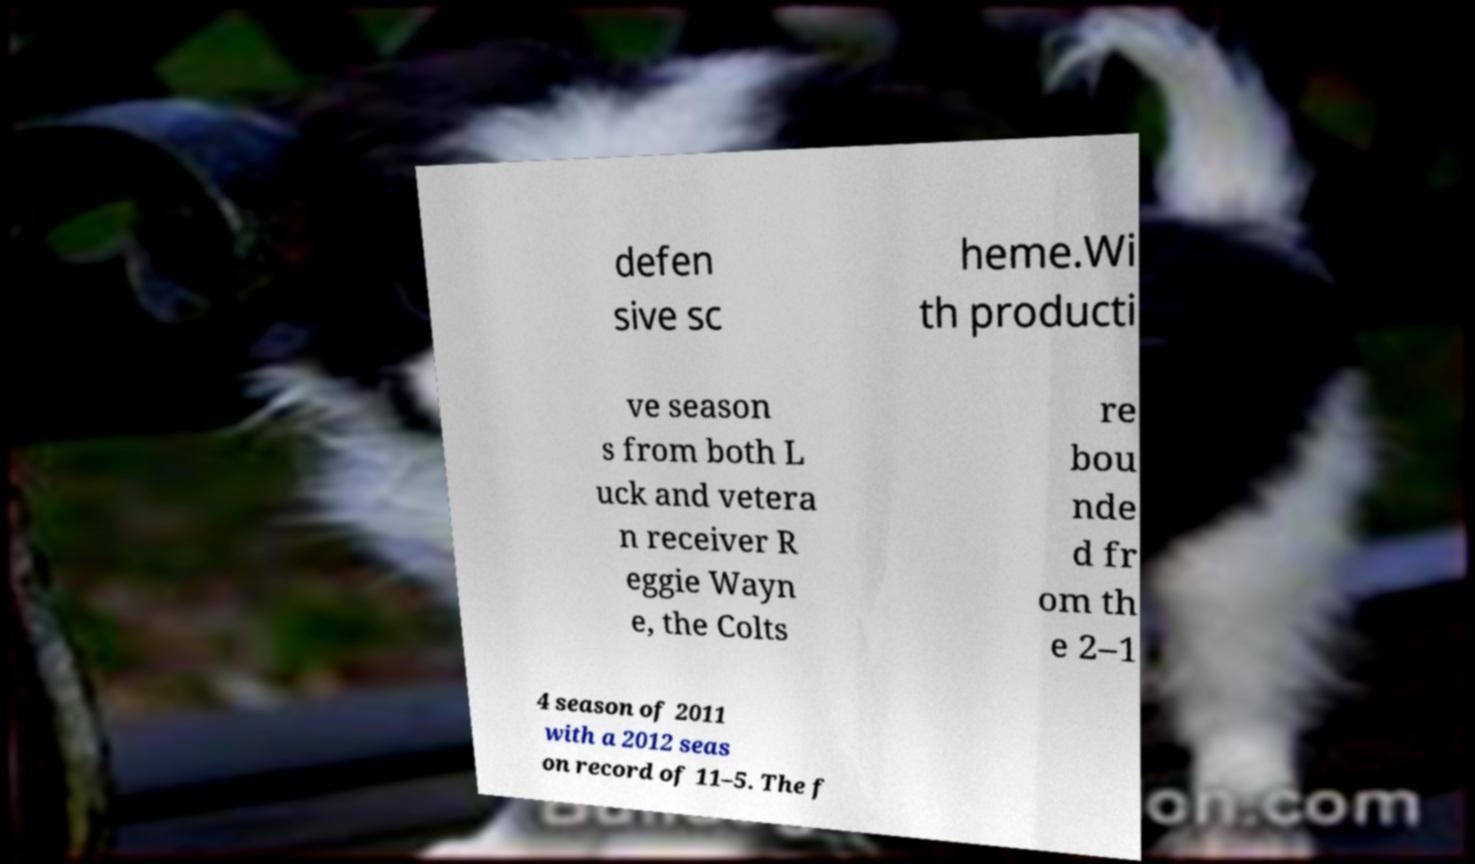Could you assist in decoding the text presented in this image and type it out clearly? defen sive sc heme.Wi th producti ve season s from both L uck and vetera n receiver R eggie Wayn e, the Colts re bou nde d fr om th e 2–1 4 season of 2011 with a 2012 seas on record of 11–5. The f 